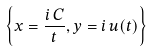Convert formula to latex. <formula><loc_0><loc_0><loc_500><loc_500>\left \{ x = { \frac { i \, C } { t } } , y = i \, u ( t ) \right \}</formula> 